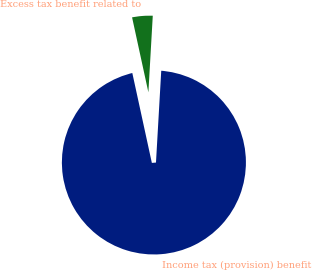<chart> <loc_0><loc_0><loc_500><loc_500><pie_chart><fcel>Income tax (provision) benefit<fcel>Excess tax benefit related to<nl><fcel>95.68%<fcel>4.32%<nl></chart> 